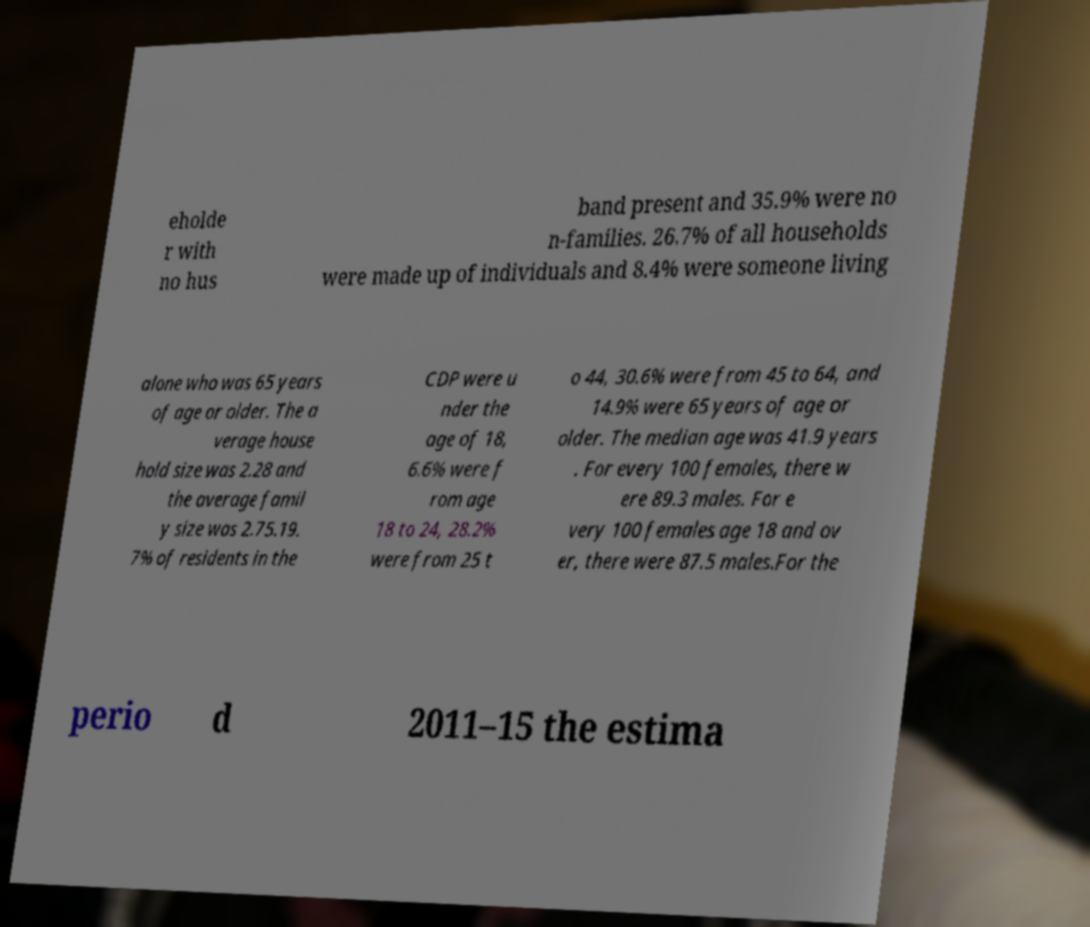Could you extract and type out the text from this image? eholde r with no hus band present and 35.9% were no n-families. 26.7% of all households were made up of individuals and 8.4% were someone living alone who was 65 years of age or older. The a verage house hold size was 2.28 and the average famil y size was 2.75.19. 7% of residents in the CDP were u nder the age of 18, 6.6% were f rom age 18 to 24, 28.2% were from 25 t o 44, 30.6% were from 45 to 64, and 14.9% were 65 years of age or older. The median age was 41.9 years . For every 100 females, there w ere 89.3 males. For e very 100 females age 18 and ov er, there were 87.5 males.For the perio d 2011–15 the estima 